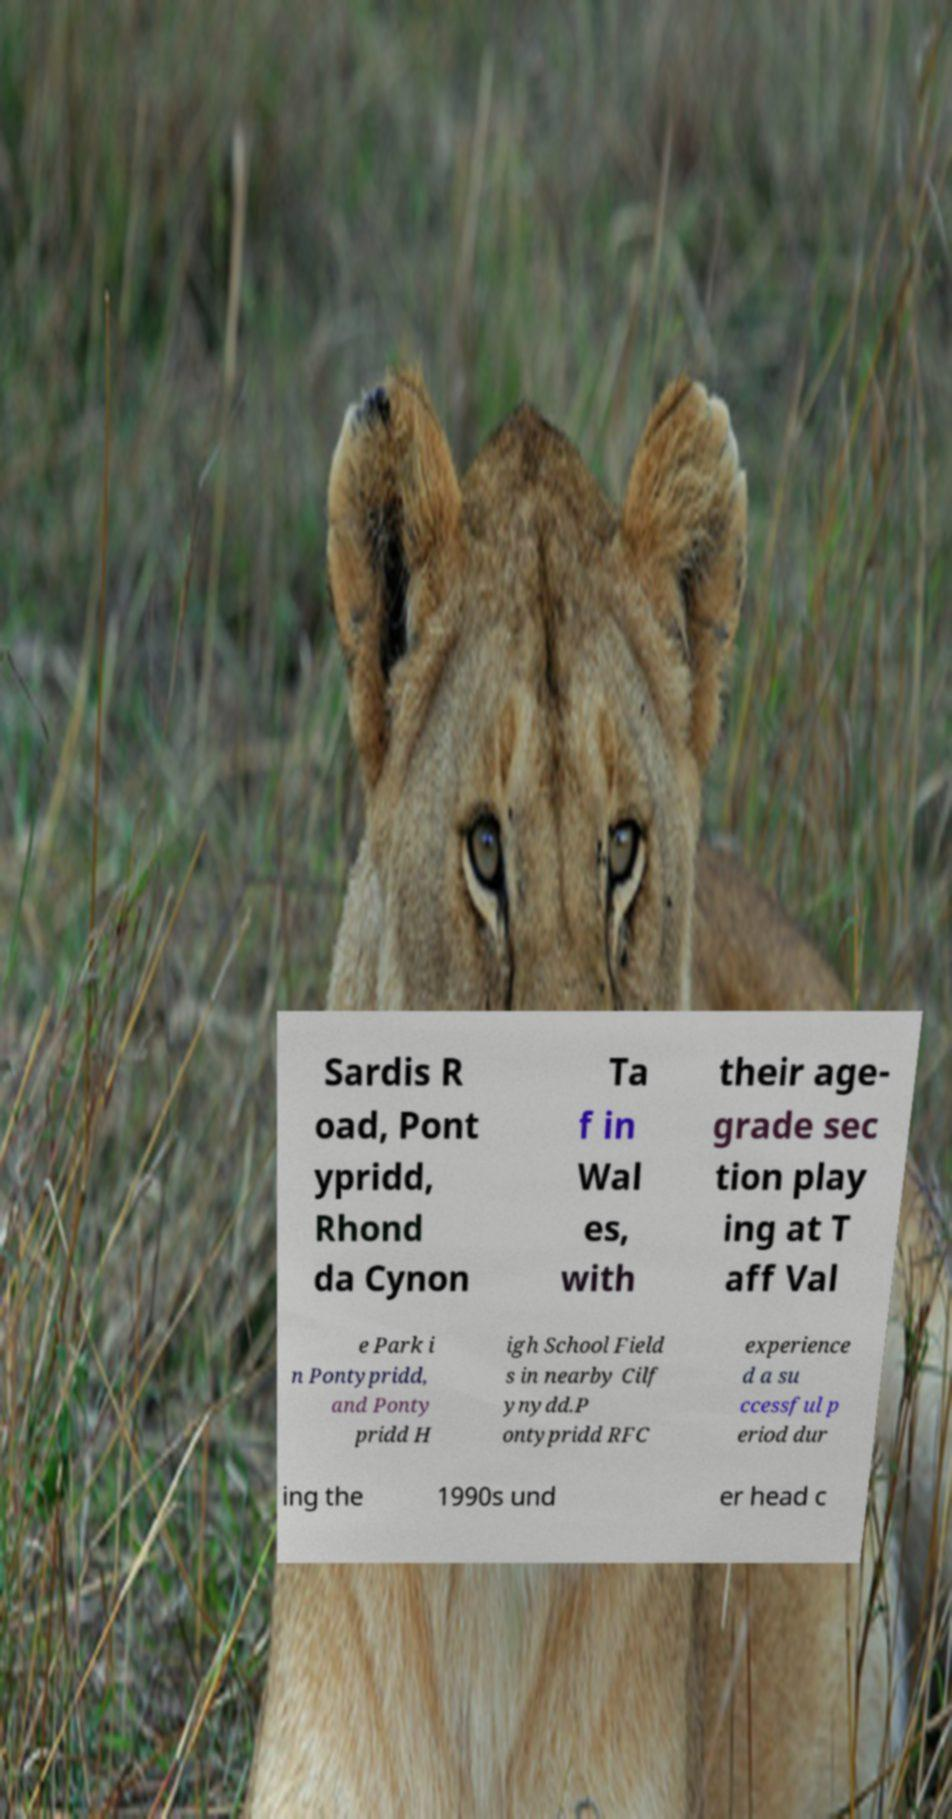Can you accurately transcribe the text from the provided image for me? Sardis R oad, Pont ypridd, Rhond da Cynon Ta f in Wal es, with their age- grade sec tion play ing at T aff Val e Park i n Pontypridd, and Ponty pridd H igh School Field s in nearby Cilf ynydd.P ontypridd RFC experience d a su ccessful p eriod dur ing the 1990s und er head c 